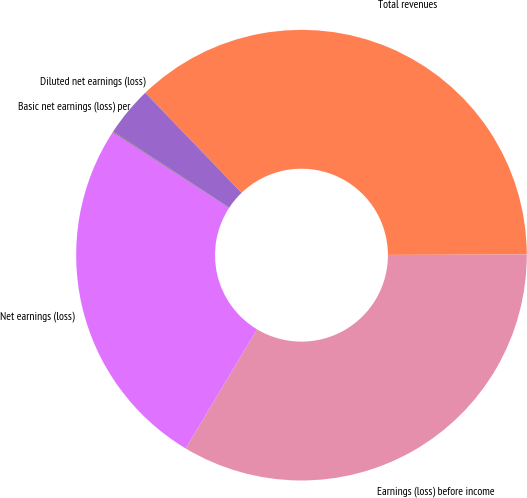Convert chart. <chart><loc_0><loc_0><loc_500><loc_500><pie_chart><fcel>Total revenues<fcel>Earnings (loss) before income<fcel>Net earnings (loss)<fcel>Basic net earnings (loss) per<fcel>Diluted net earnings (loss)<nl><fcel>37.14%<fcel>33.64%<fcel>25.61%<fcel>0.05%<fcel>3.56%<nl></chart> 